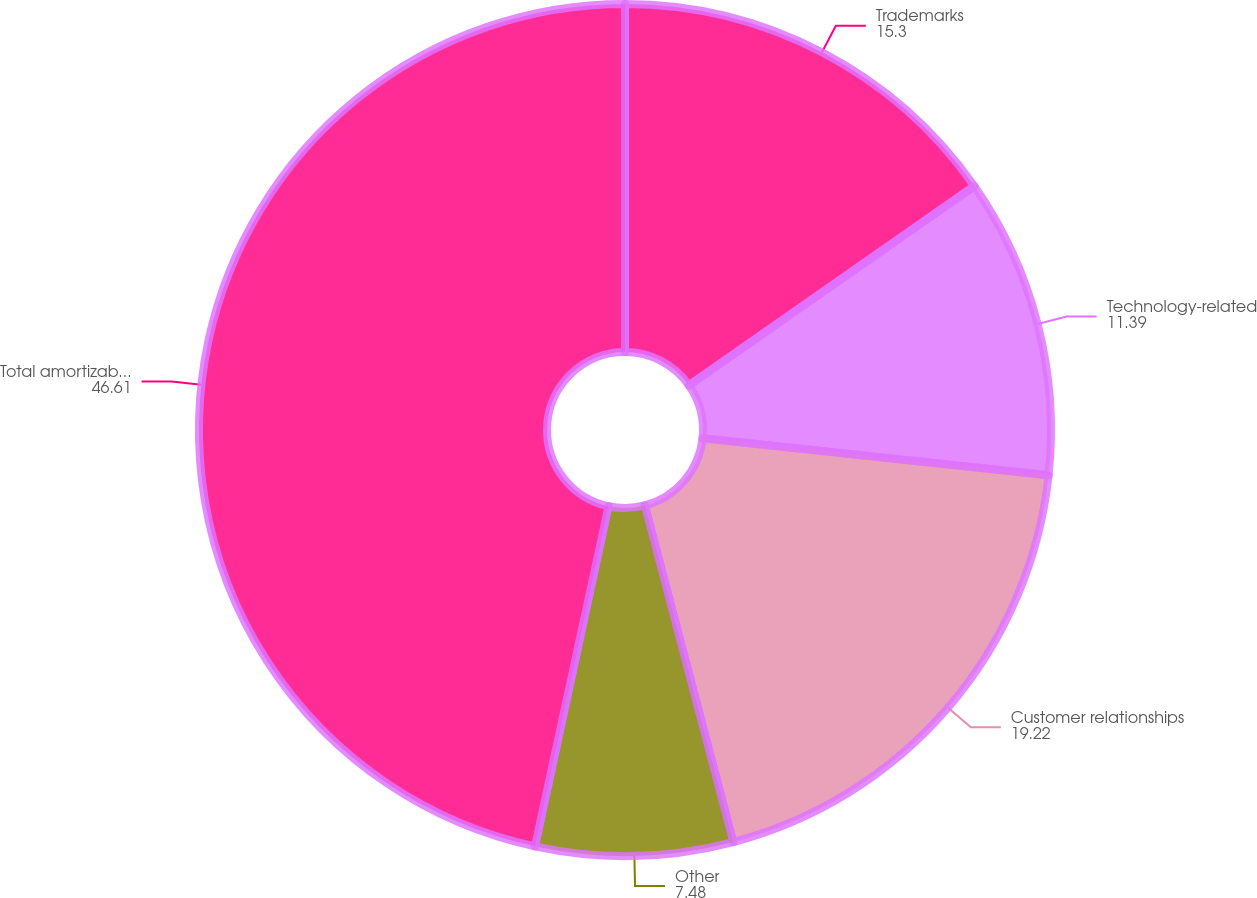Convert chart. <chart><loc_0><loc_0><loc_500><loc_500><pie_chart><fcel>Trademarks<fcel>Technology-related<fcel>Customer relationships<fcel>Other<fcel>Total amortizable intangible<nl><fcel>15.3%<fcel>11.39%<fcel>19.22%<fcel>7.48%<fcel>46.61%<nl></chart> 